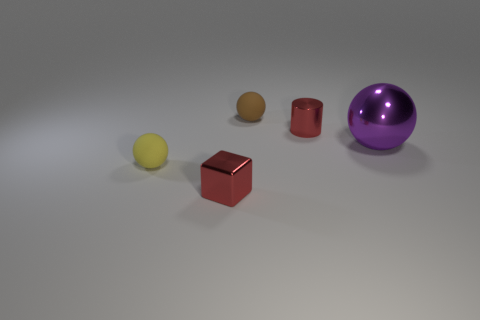There is a purple object that is the same shape as the brown matte object; what size is it?
Your answer should be very brief. Large. What number of cubes are yellow matte things or small red things?
Keep it short and to the point. 1. What is the material of the cylinder that is the same color as the tiny cube?
Provide a short and direct response. Metal. Are there fewer tiny cubes that are to the left of the shiny block than small metal blocks that are to the right of the small metal cylinder?
Your answer should be very brief. No. How many objects are either small rubber spheres on the left side of the tiny brown matte object or cyan objects?
Your answer should be compact. 1. The rubber thing on the left side of the brown rubber thing behind the big purple sphere is what shape?
Provide a succinct answer. Sphere. Are there any metallic blocks of the same size as the cylinder?
Offer a very short reply. Yes. Are there more red things than brown matte spheres?
Give a very brief answer. Yes. There is a matte thing in front of the brown matte sphere; is it the same size as the shiny object to the left of the tiny red metallic cylinder?
Your answer should be compact. Yes. How many matte objects are behind the small red metallic cylinder and in front of the brown rubber sphere?
Give a very brief answer. 0. 